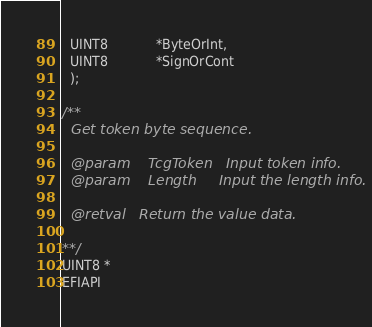<code> <loc_0><loc_0><loc_500><loc_500><_C_>  UINT8            *ByteOrInt,
  UINT8            *SignOrCont
  );

/**
  Get token byte sequence.

  @param    TcgToken   Input token info.
  @param    Length     Input the length info.

  @retval   Return the value data.

**/
UINT8 *
EFIAPI</code> 